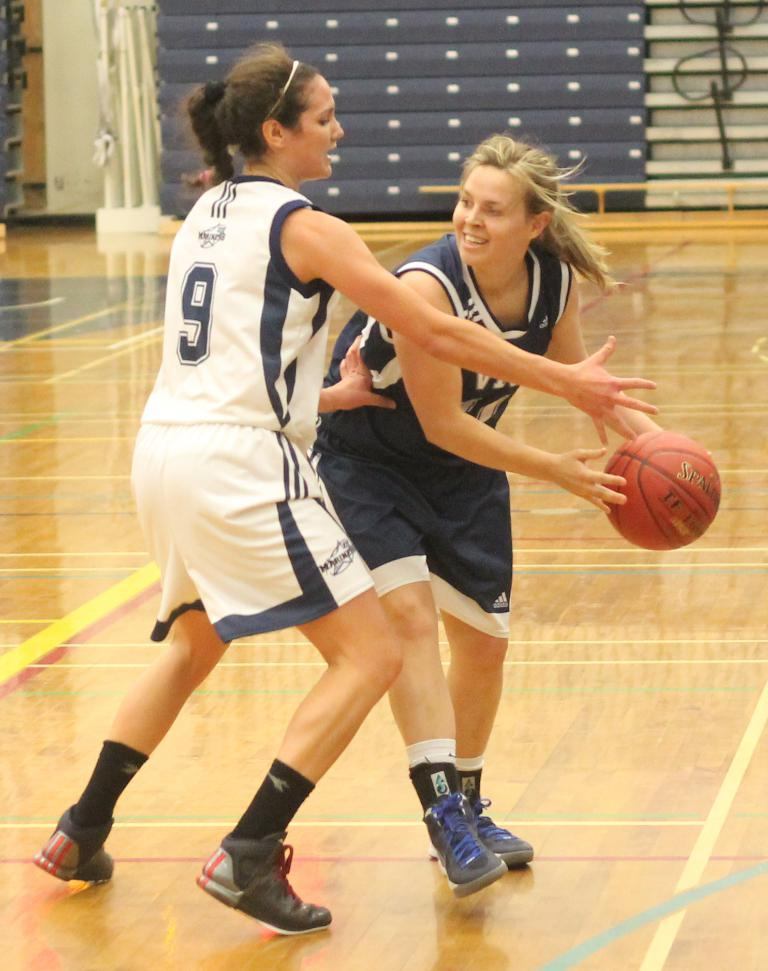<image>
Provide a brief description of the given image. Number 9 is the girl wearing the white jersey. 